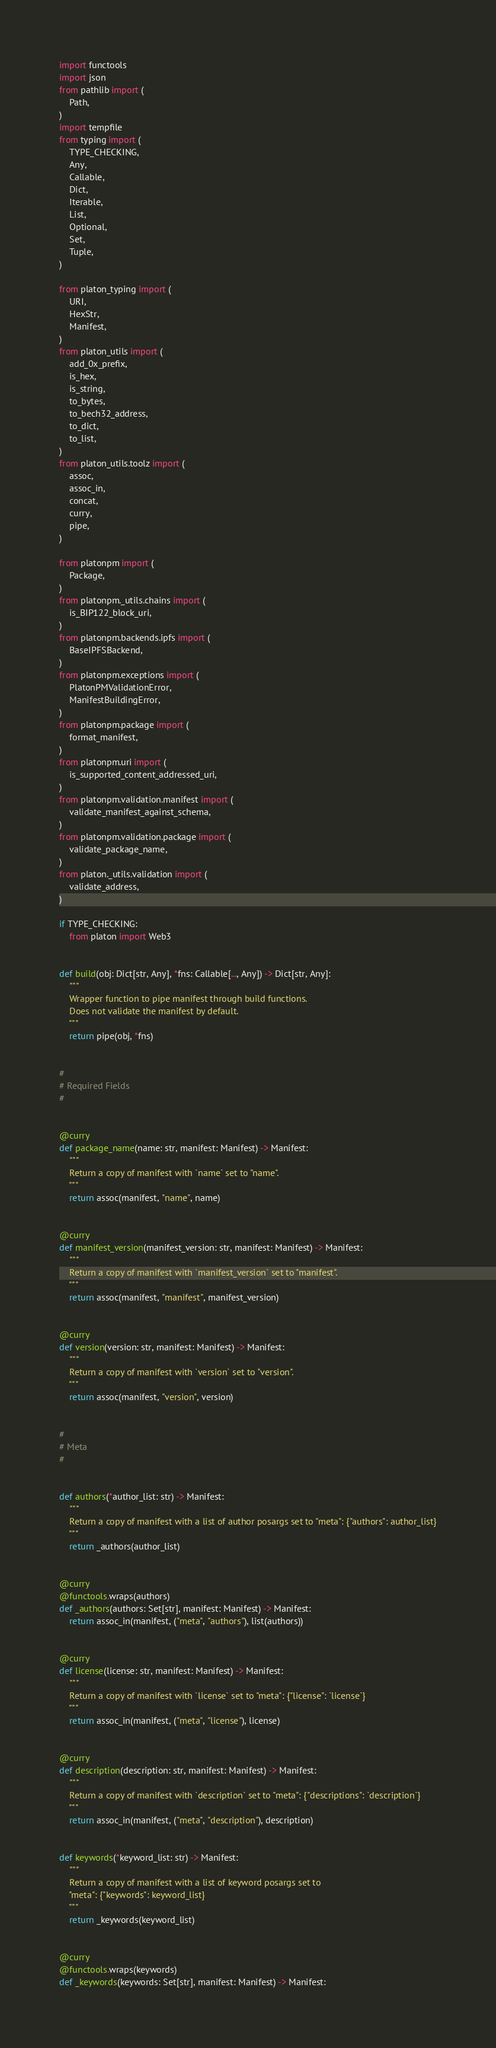<code> <loc_0><loc_0><loc_500><loc_500><_Python_>import functools
import json
from pathlib import (
    Path,
)
import tempfile
from typing import (
    TYPE_CHECKING,
    Any,
    Callable,
    Dict,
    Iterable,
    List,
    Optional,
    Set,
    Tuple,
)

from platon_typing import (
    URI,
    HexStr,
    Manifest,
)
from platon_utils import (
    add_0x_prefix,
    is_hex,
    is_string,
    to_bytes,
    to_bech32_address,
    to_dict,
    to_list,
)
from platon_utils.toolz import (
    assoc,
    assoc_in,
    concat,
    curry,
    pipe,
)

from platonpm import (
    Package,
)
from platonpm._utils.chains import (
    is_BIP122_block_uri,
)
from platonpm.backends.ipfs import (
    BaseIPFSBackend,
)
from platonpm.exceptions import (
    PlatonPMValidationError,
    ManifestBuildingError,
)
from platonpm.package import (
    format_manifest,
)
from platonpm.uri import (
    is_supported_content_addressed_uri,
)
from platonpm.validation.manifest import (
    validate_manifest_against_schema,
)
from platonpm.validation.package import (
    validate_package_name,
)
from platon._utils.validation import (
    validate_address,
)

if TYPE_CHECKING:
    from platon import Web3


def build(obj: Dict[str, Any], *fns: Callable[..., Any]) -> Dict[str, Any]:
    """
    Wrapper function to pipe manifest through build functions.
    Does not validate the manifest by default.
    """
    return pipe(obj, *fns)


#
# Required Fields
#


@curry
def package_name(name: str, manifest: Manifest) -> Manifest:
    """
    Return a copy of manifest with `name` set to "name".
    """
    return assoc(manifest, "name", name)


@curry
def manifest_version(manifest_version: str, manifest: Manifest) -> Manifest:
    """
    Return a copy of manifest with `manifest_version` set to "manifest".
    """
    return assoc(manifest, "manifest", manifest_version)


@curry
def version(version: str, manifest: Manifest) -> Manifest:
    """
    Return a copy of manifest with `version` set to "version".
    """
    return assoc(manifest, "version", version)


#
# Meta
#


def authors(*author_list: str) -> Manifest:
    """
    Return a copy of manifest with a list of author posargs set to "meta": {"authors": author_list}
    """
    return _authors(author_list)


@curry
@functools.wraps(authors)
def _authors(authors: Set[str], manifest: Manifest) -> Manifest:
    return assoc_in(manifest, ("meta", "authors"), list(authors))


@curry
def license(license: str, manifest: Manifest) -> Manifest:
    """
    Return a copy of manifest with `license` set to "meta": {"license": `license`}
    """
    return assoc_in(manifest, ("meta", "license"), license)


@curry
def description(description: str, manifest: Manifest) -> Manifest:
    """
    Return a copy of manifest with `description` set to "meta": {"descriptions": `description`}
    """
    return assoc_in(manifest, ("meta", "description"), description)


def keywords(*keyword_list: str) -> Manifest:
    """
    Return a copy of manifest with a list of keyword posargs set to
    "meta": {"keywords": keyword_list}
    """
    return _keywords(keyword_list)


@curry
@functools.wraps(keywords)
def _keywords(keywords: Set[str], manifest: Manifest) -> Manifest:</code> 